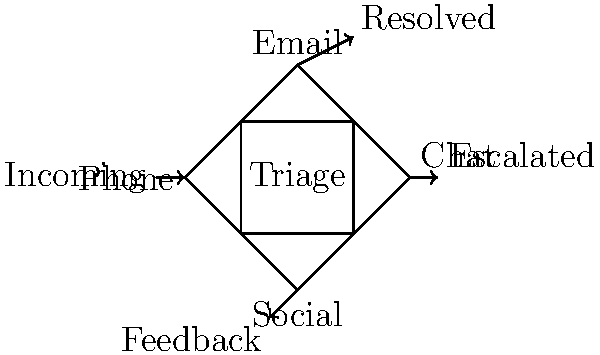In the customer inquiry flow diagram, which channel is most likely to require a balance between traditional methods and modern service expectations? To answer this question, let's analyze each channel in the context of balancing traditional methods with modern service expectations:

1. Phone: This is the most traditional channel, often preferred by older customers or for complex issues. It requires personal interaction but may need modernization in terms of wait times and automated systems.

2. Email: A relatively modern channel that allows for detailed responses but may lack the immediacy customers now expect.

3. Chat: A modern channel that provides instant communication but may challenge traditional customer service scripts and response times.

4. Social: The most modern channel, requiring quick responses and public interaction, which can be at odds with traditional customer service approaches.

5. Triage: The central process of routing inquiries, which needs to balance efficient traditional methods with the varied expectations of modern channels.

Considering the persona of a customer service representative trying to balance traditional methods with modern demands, the phone channel presents the most significant challenge. It's the most traditional method that many customers still prefer, but it needs to be modernized to meet current expectations for efficiency and convenience.

The phone channel requires balancing:
- Traditional personal service with modern efficiency
- Detailed problem-solving with quicker resolution times
- Familiar scripts with more flexible, personalized responses
- Standard business hours with expectations for extended availability

Therefore, the phone channel is most likely to require a careful balance between traditional methods and modern service expectations.
Answer: Phone 